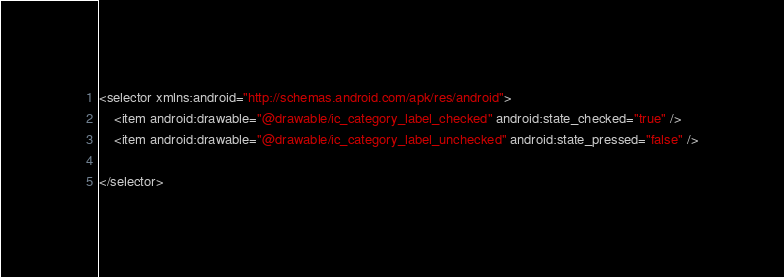<code> <loc_0><loc_0><loc_500><loc_500><_XML_><selector xmlns:android="http://schemas.android.com/apk/res/android">
    <item android:drawable="@drawable/ic_category_label_checked" android:state_checked="true" />
    <item android:drawable="@drawable/ic_category_label_unchecked" android:state_pressed="false" />

</selector>
</code> 